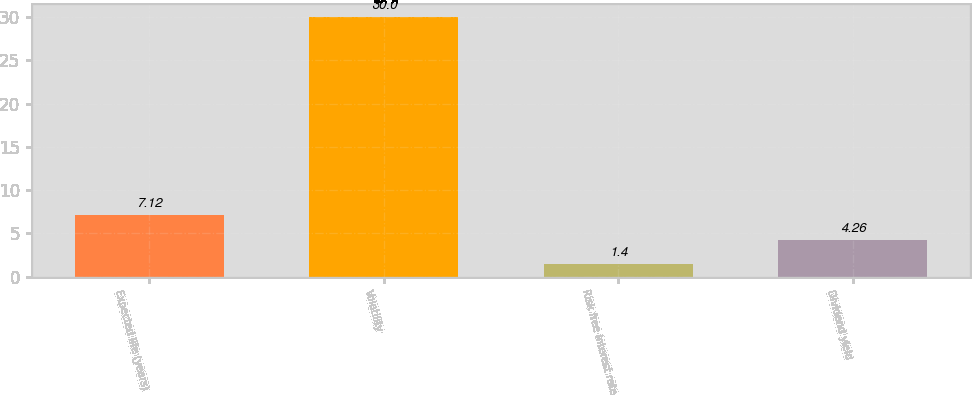<chart> <loc_0><loc_0><loc_500><loc_500><bar_chart><fcel>Expected life (years)<fcel>Volatility<fcel>Risk free interest rate<fcel>Dividend yield<nl><fcel>7.12<fcel>30<fcel>1.4<fcel>4.26<nl></chart> 